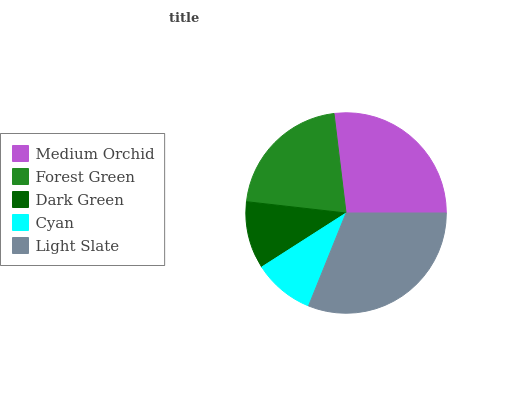Is Cyan the minimum?
Answer yes or no. Yes. Is Light Slate the maximum?
Answer yes or no. Yes. Is Forest Green the minimum?
Answer yes or no. No. Is Forest Green the maximum?
Answer yes or no. No. Is Medium Orchid greater than Forest Green?
Answer yes or no. Yes. Is Forest Green less than Medium Orchid?
Answer yes or no. Yes. Is Forest Green greater than Medium Orchid?
Answer yes or no. No. Is Medium Orchid less than Forest Green?
Answer yes or no. No. Is Forest Green the high median?
Answer yes or no. Yes. Is Forest Green the low median?
Answer yes or no. Yes. Is Dark Green the high median?
Answer yes or no. No. Is Cyan the low median?
Answer yes or no. No. 